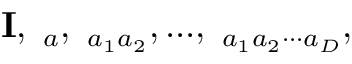<formula> <loc_0><loc_0><loc_500><loc_500>{ I } , { \Gamma } _ { a } , { \Gamma } _ { a _ { 1 } a _ { 2 } } , \dots , { \Gamma } _ { a _ { 1 } a _ { 2 } \cdot \cdot \cdot a _ { D } } ,</formula> 